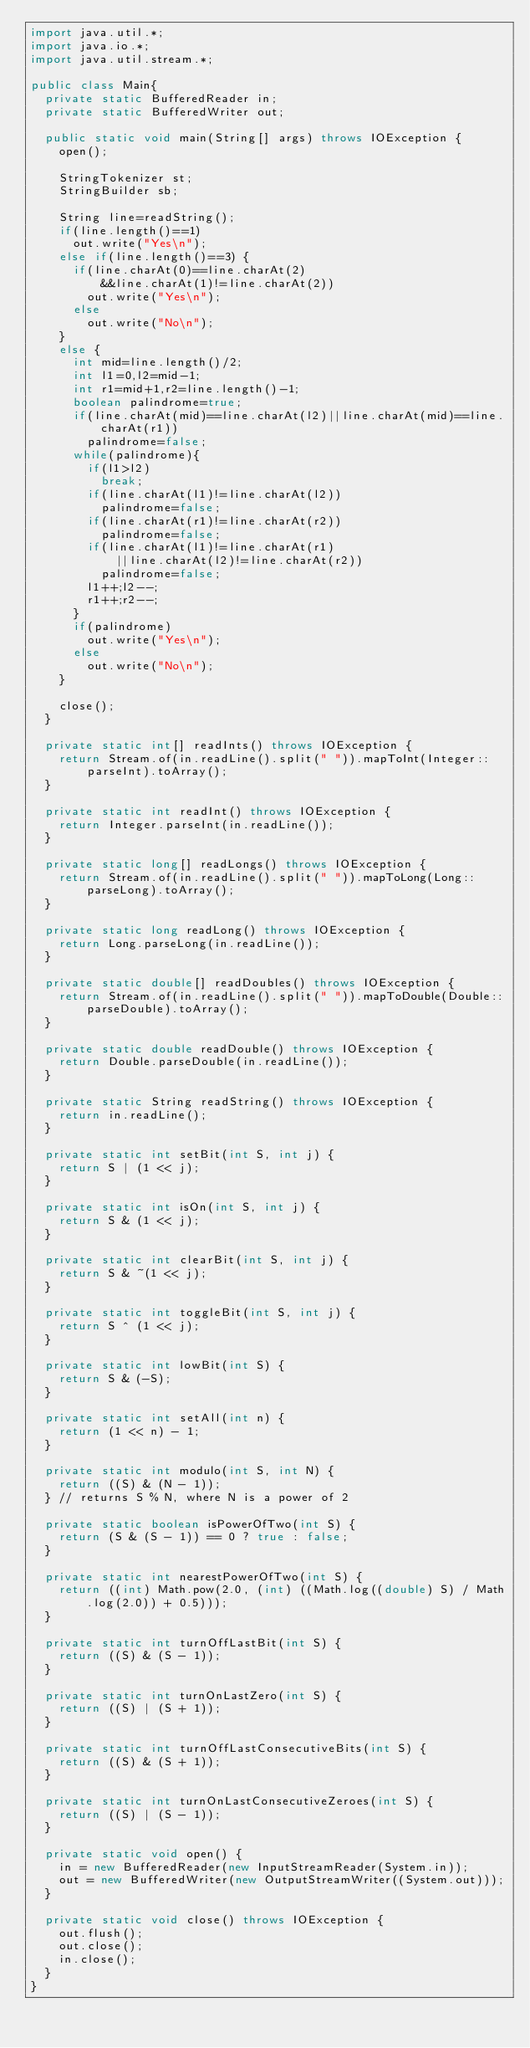Convert code to text. <code><loc_0><loc_0><loc_500><loc_500><_Java_>import java.util.*;
import java.io.*;
import java.util.stream.*;

public class Main{
	private static BufferedReader in;
	private static BufferedWriter out;
	
	public static void main(String[] args) throws IOException {
		open();

		StringTokenizer st;
		StringBuilder sb;
		
		String line=readString();
		if(line.length()==1)
			out.write("Yes\n");
		else if(line.length()==3) {
			if(line.charAt(0)==line.charAt(2)
					&&line.charAt(1)!=line.charAt(2))
				out.write("Yes\n");
			else
				out.write("No\n");
		}
		else {
			int mid=line.length()/2;
			int l1=0,l2=mid-1;
			int r1=mid+1,r2=line.length()-1;
			boolean palindrome=true;
			if(line.charAt(mid)==line.charAt(l2)||line.charAt(mid)==line.charAt(r1))
				palindrome=false;
			while(palindrome){
				if(l1>l2)
					break;
				if(line.charAt(l1)!=line.charAt(l2))
					palindrome=false;
				if(line.charAt(r1)!=line.charAt(r2))
					palindrome=false;
				if(line.charAt(l1)!=line.charAt(r1)
						||line.charAt(l2)!=line.charAt(r2))
					palindrome=false;
				l1++;l2--;
				r1++;r2--;
			}
			if(palindrome)
				out.write("Yes\n");
			else
				out.write("No\n");
		}
		
		close();
	}
	
	private static int[] readInts() throws IOException {
		return Stream.of(in.readLine().split(" ")).mapToInt(Integer::parseInt).toArray();
	}

	private static int readInt() throws IOException {
		return Integer.parseInt(in.readLine());
	}

	private static long[] readLongs() throws IOException {
		return Stream.of(in.readLine().split(" ")).mapToLong(Long::parseLong).toArray();
	}

	private static long readLong() throws IOException {
		return Long.parseLong(in.readLine());
	}

	private static double[] readDoubles() throws IOException {
		return Stream.of(in.readLine().split(" ")).mapToDouble(Double::parseDouble).toArray();
	}

	private static double readDouble() throws IOException {
		return Double.parseDouble(in.readLine());
	}

	private static String readString() throws IOException {
		return in.readLine();
	}

	private static int setBit(int S, int j) {
		return S | (1 << j);
	}

	private static int isOn(int S, int j) {
		return S & (1 << j);
	}

	private static int clearBit(int S, int j) {
		return S & ~(1 << j);
	}

	private static int toggleBit(int S, int j) {
		return S ^ (1 << j);
	}

	private static int lowBit(int S) {
		return S & (-S);
	}

	private static int setAll(int n) {
		return (1 << n) - 1;
	}

	private static int modulo(int S, int N) {
		return ((S) & (N - 1));
	} // returns S % N, where N is a power of 2

	private static boolean isPowerOfTwo(int S) {
		return (S & (S - 1)) == 0 ? true : false;
	}

	private static int nearestPowerOfTwo(int S) {
		return ((int) Math.pow(2.0, (int) ((Math.log((double) S) / Math.log(2.0)) + 0.5)));
	}

	private static int turnOffLastBit(int S) {
		return ((S) & (S - 1));
	}

	private static int turnOnLastZero(int S) {
		return ((S) | (S + 1));
	}

	private static int turnOffLastConsecutiveBits(int S) {
		return ((S) & (S + 1));
	}

	private static int turnOnLastConsecutiveZeroes(int S) {
		return ((S) | (S - 1));
	}

	private static void open() {
		in = new BufferedReader(new InputStreamReader(System.in));
		out = new BufferedWriter(new OutputStreamWriter((System.out)));
	}

	private static void close() throws IOException {
		out.flush();
		out.close();
		in.close();
	}
}</code> 